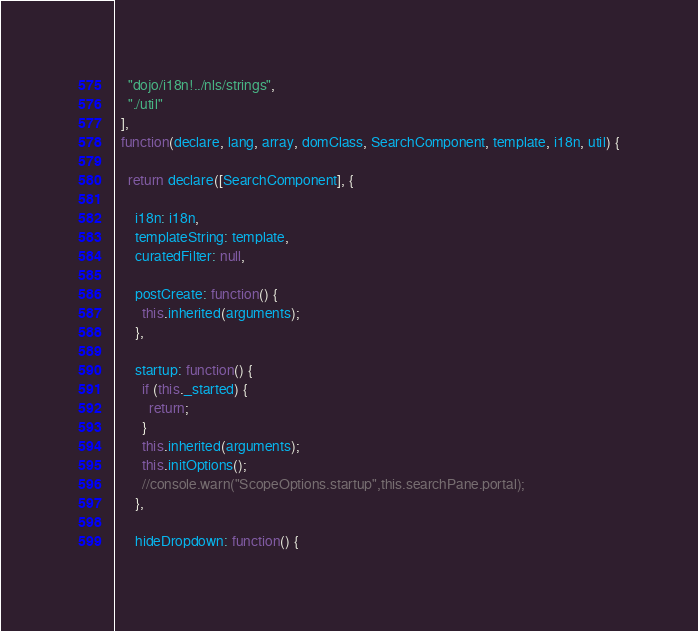Convert code to text. <code><loc_0><loc_0><loc_500><loc_500><_JavaScript_>    "dojo/i18n!../nls/strings",
    "./util"
  ],
  function(declare, lang, array, domClass, SearchComponent, template, i18n, util) {

    return declare([SearchComponent], {

      i18n: i18n,
      templateString: template,
      curatedFilter: null,

      postCreate: function() {
        this.inherited(arguments);
      },

      startup: function() {
        if (this._started) {
          return;
        }
        this.inherited(arguments);
        this.initOptions();
        //console.warn("ScopeOptions.startup",this.searchPane.portal);
      },

      hideDropdown: function() {</code> 